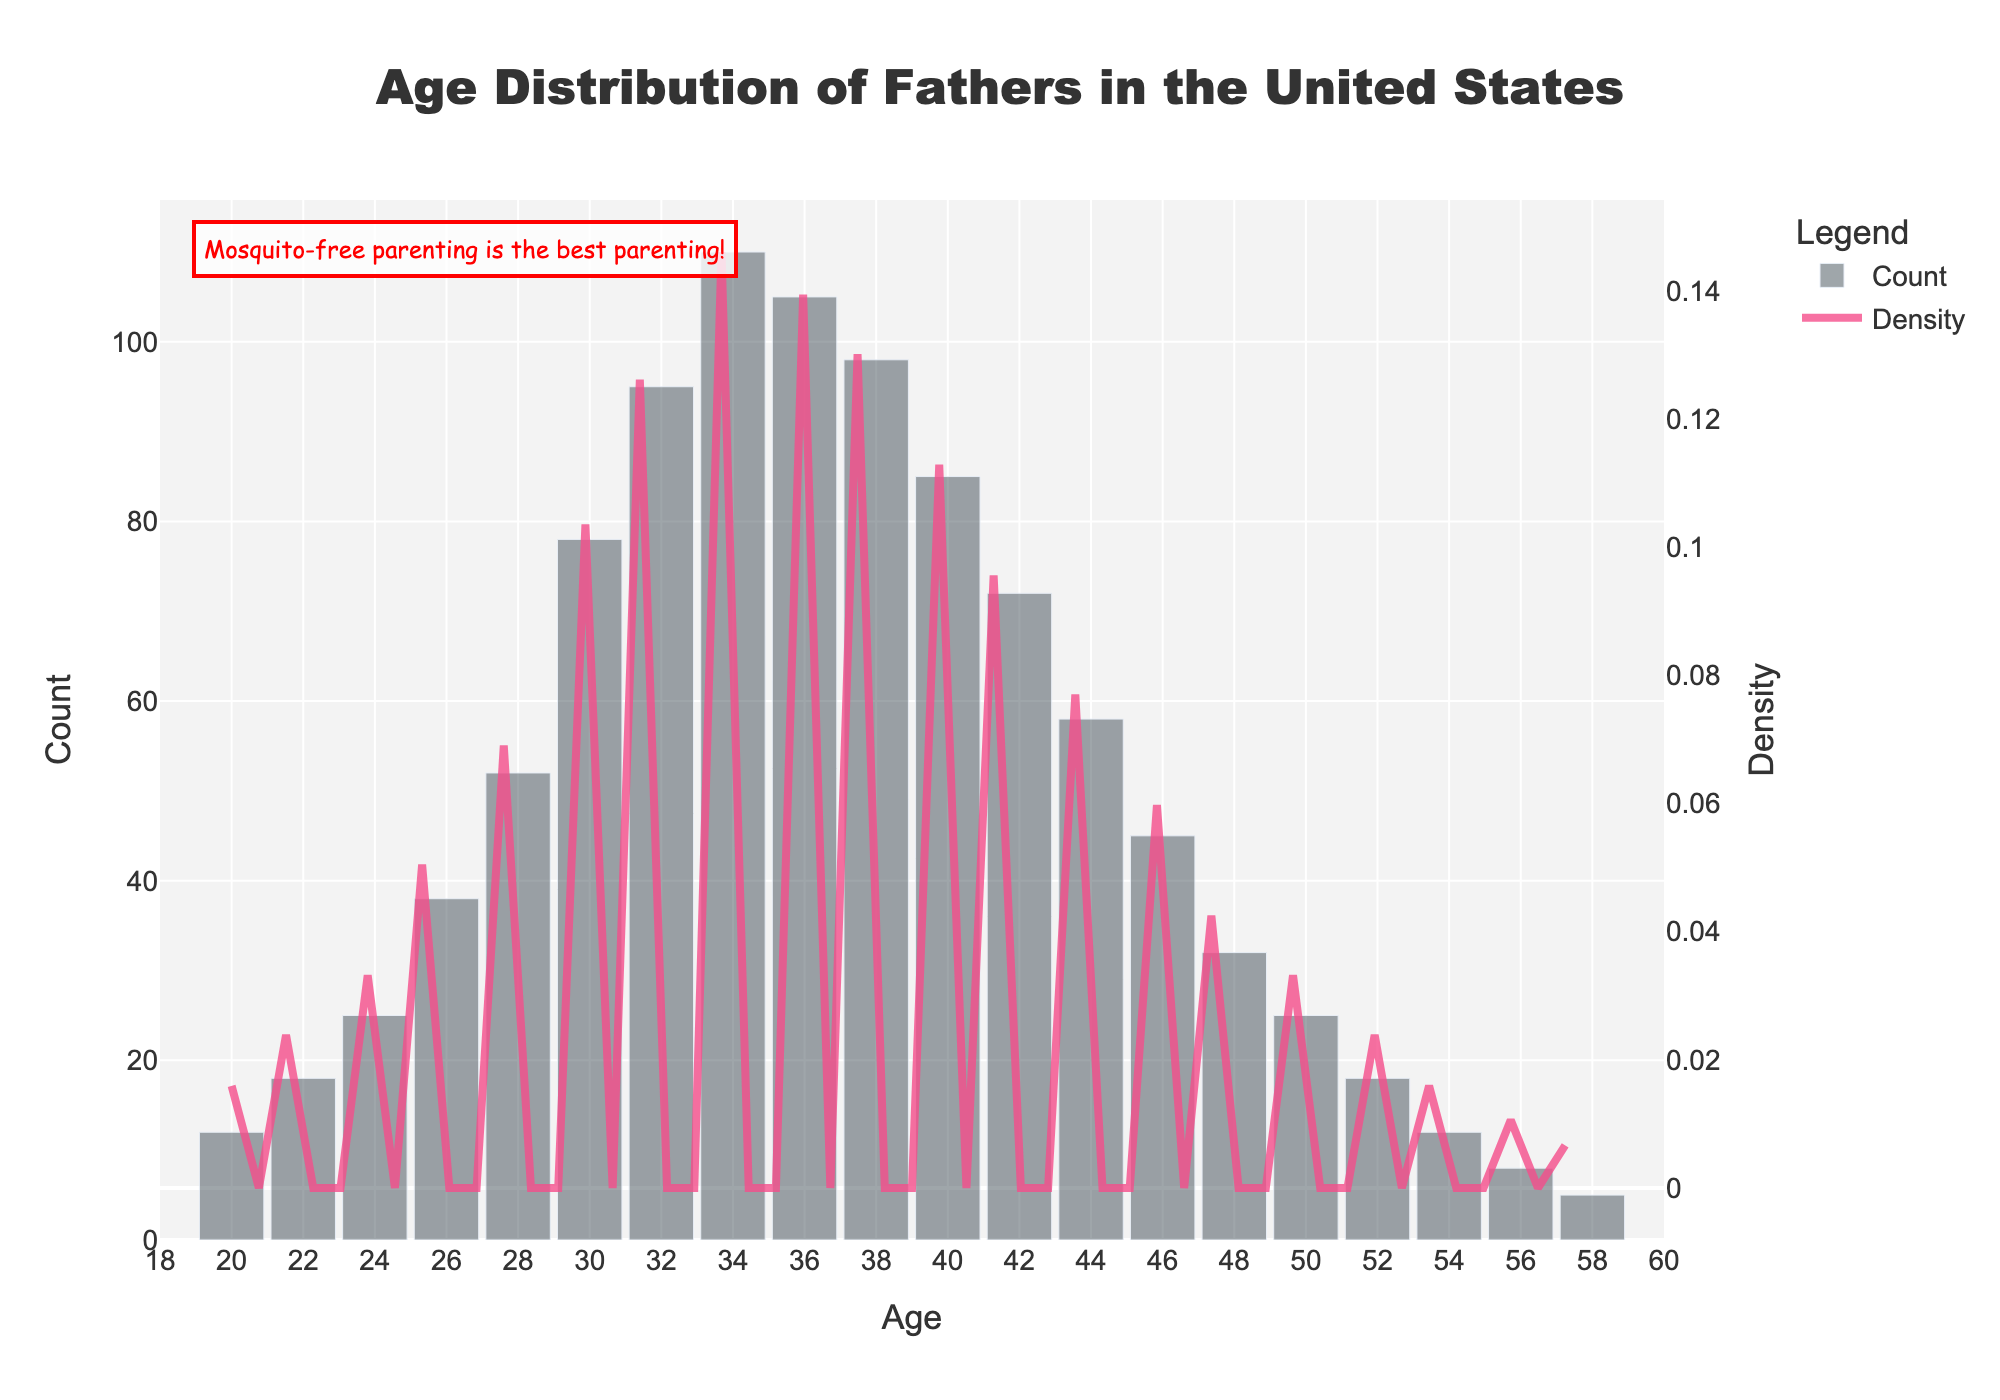what is the title of the figure? The title is prominently displayed at the top of the figure and usually gives a concise description of what the figure is about.
Answer: Age Distribution of Fathers in the United States What is the count of fathers aged 30? The histogram bar at age 30 shows the height representing the count value which is labeled directly above or within the bar.
Answer: 78 How is the y-axis on the left titled? The y-axis on the left shows the count of fathers for different ages, so its title reflects this measurement.
Answer: Count Which age group has the highest count of fathers? The histogram bars represent the count of fathers across different ages. By observing the height of the bars, the age with the highest bar indicates the highest count.
Answer: 34 What is the y-axis on the right titled? The y-axis on the right indicates the density of the distribution, as shown by the KDE (density curve) plotted across the histogram.
Answer: Density At which age does the density curve peak? Observing the KDE curve, the peak point along the age axis indicates where the highest density value occurs.
Answer: Around 34 Provide the count of fathers aged 40 and aged 42. What is the difference? Look at the height of the histogram bars for ages 40 and 42. Note the values and subtract the count of age 42 from the count of age 40.
Answer: Counts at 40=85 and at 42=72; Difference=85-72=13 Between age 28 and 50, which age has the least count? Comparing the histogram bars between age 28 and 50, the lowest bar represents the age with the least count.
Answer: 50 What is the range of ages displayed on the x-axis? The x-axis range is determined by the starting and ending points labeled along the axis.
Answer: 18 to 60 From the histogram with the KDE curve, how do count and density compare visually in the age group 34-40? The histogram (bar plot) represents actual counts, while the KDE curve represents density. Observing both, the bar heights and curve shape within the specific age range 34-40 help compare their trends.
Answer: Both peak around 34, then gradually decrease towards 40 